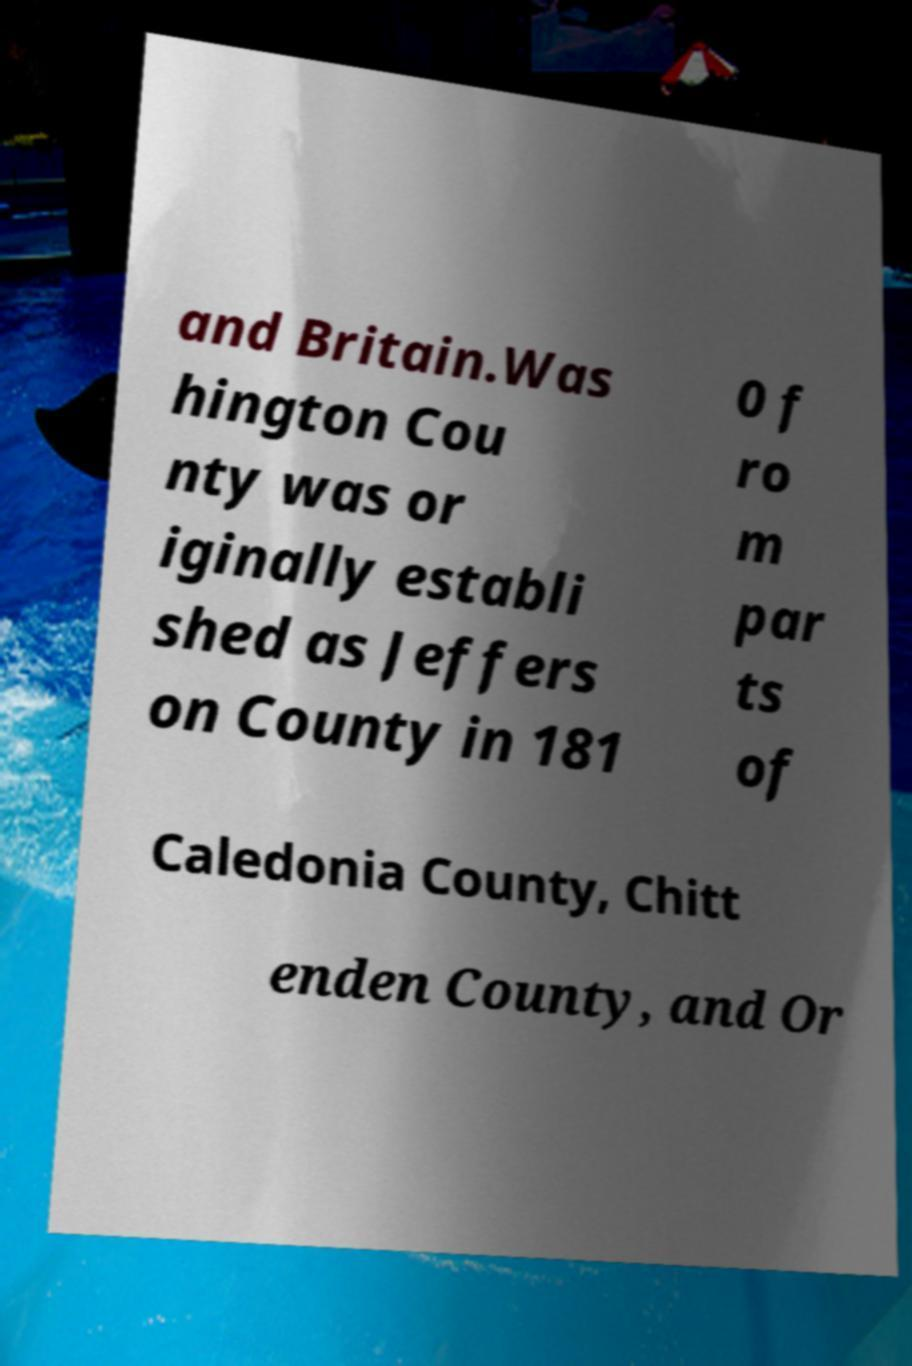Please identify and transcribe the text found in this image. and Britain.Was hington Cou nty was or iginally establi shed as Jeffers on County in 181 0 f ro m par ts of Caledonia County, Chitt enden County, and Or 